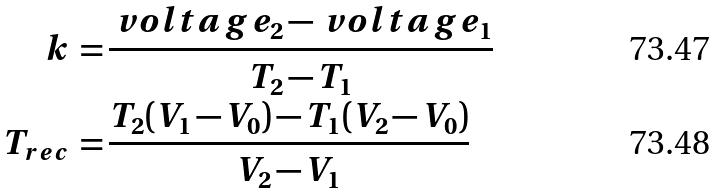<formula> <loc_0><loc_0><loc_500><loc_500>k \, = & \, \frac { \ v o l t a g e _ { 2 } - \ v o l t a g e _ { 1 } } { T _ { 2 } - T _ { 1 } } \\ T _ { r e c } \, = & \, \frac { T _ { 2 } ( V _ { 1 } - V _ { 0 } ) - T _ { 1 } ( V _ { 2 } - V _ { 0 } ) } { V _ { 2 } - V _ { 1 } }</formula> 